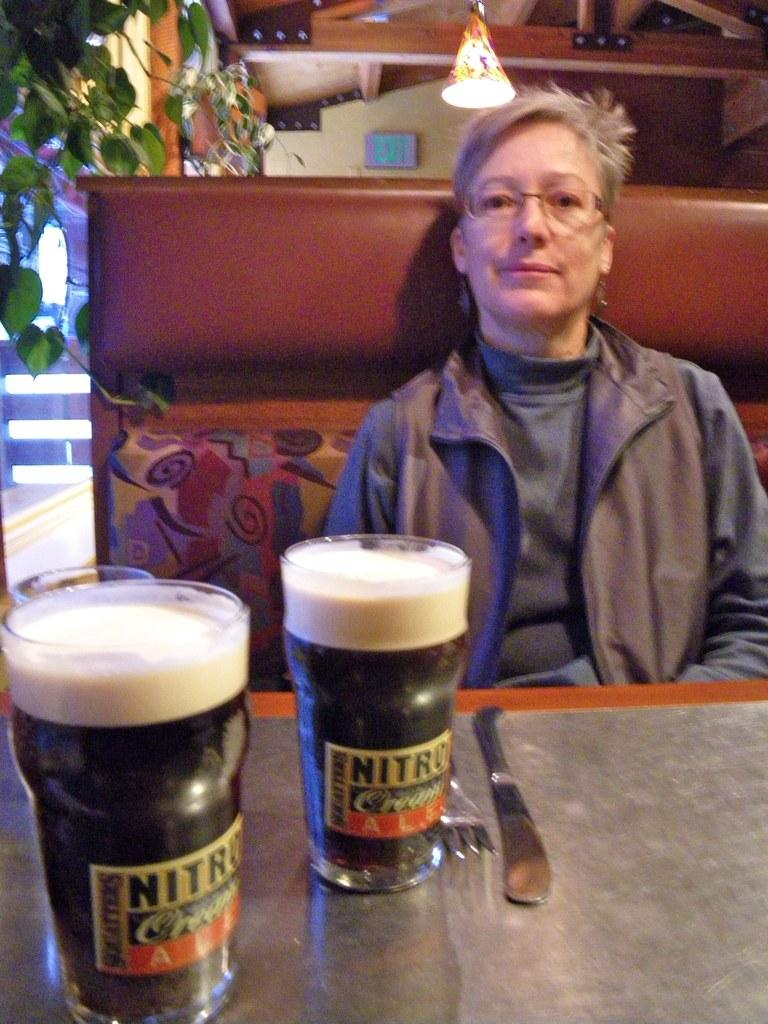<image>
Present a compact description of the photo's key features. A woman sitting at a table with a green exit sign behind her. 